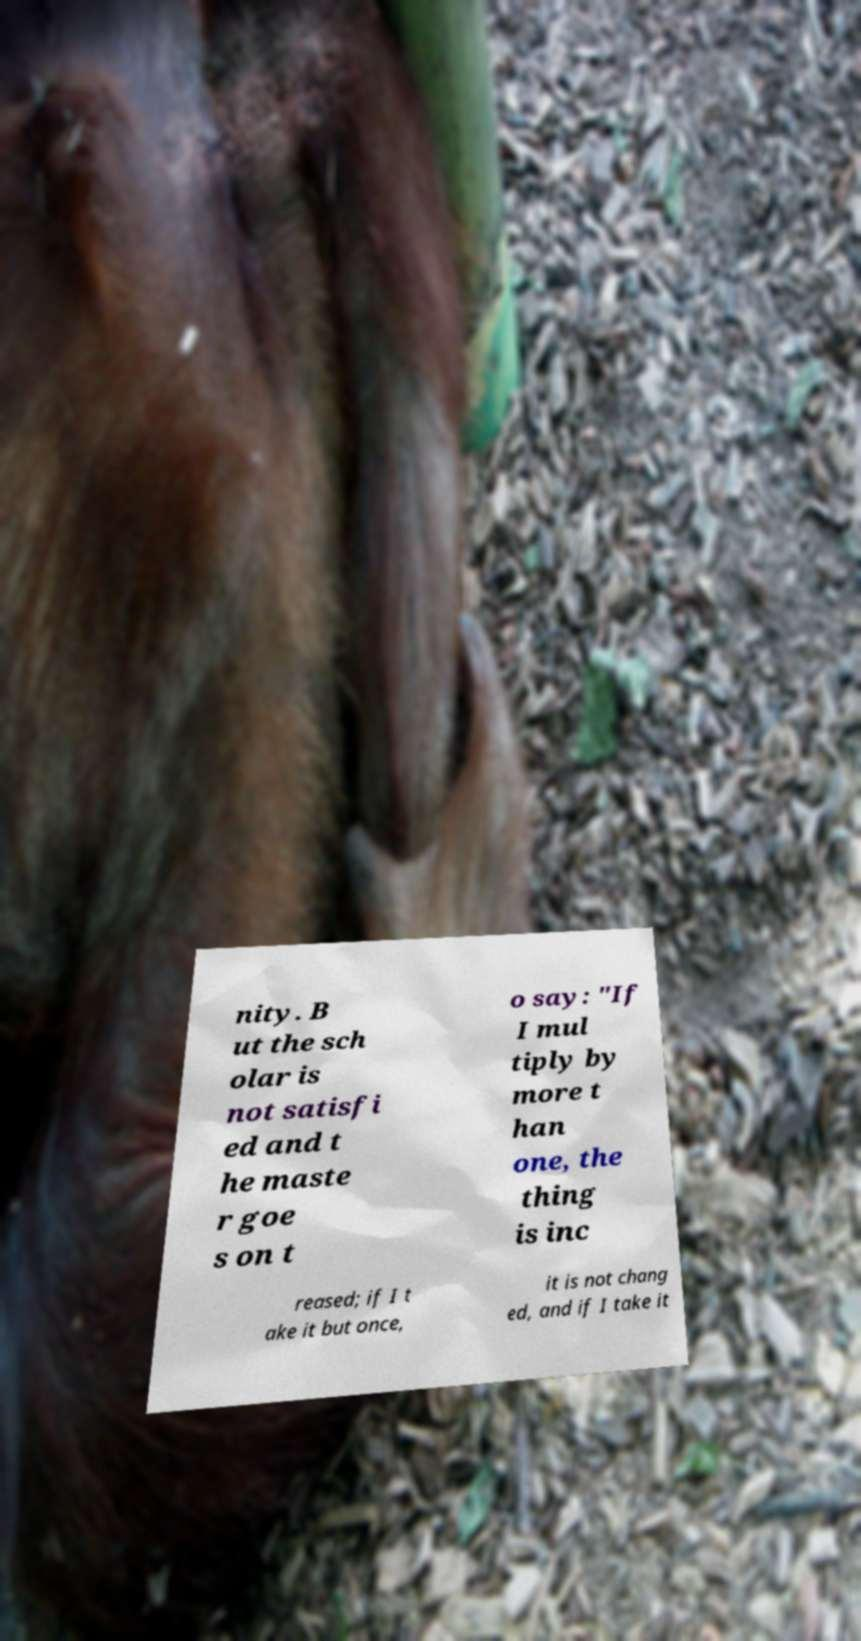Could you extract and type out the text from this image? nity. B ut the sch olar is not satisfi ed and t he maste r goe s on t o say: "If I mul tiply by more t han one, the thing is inc reased; if I t ake it but once, it is not chang ed, and if I take it 